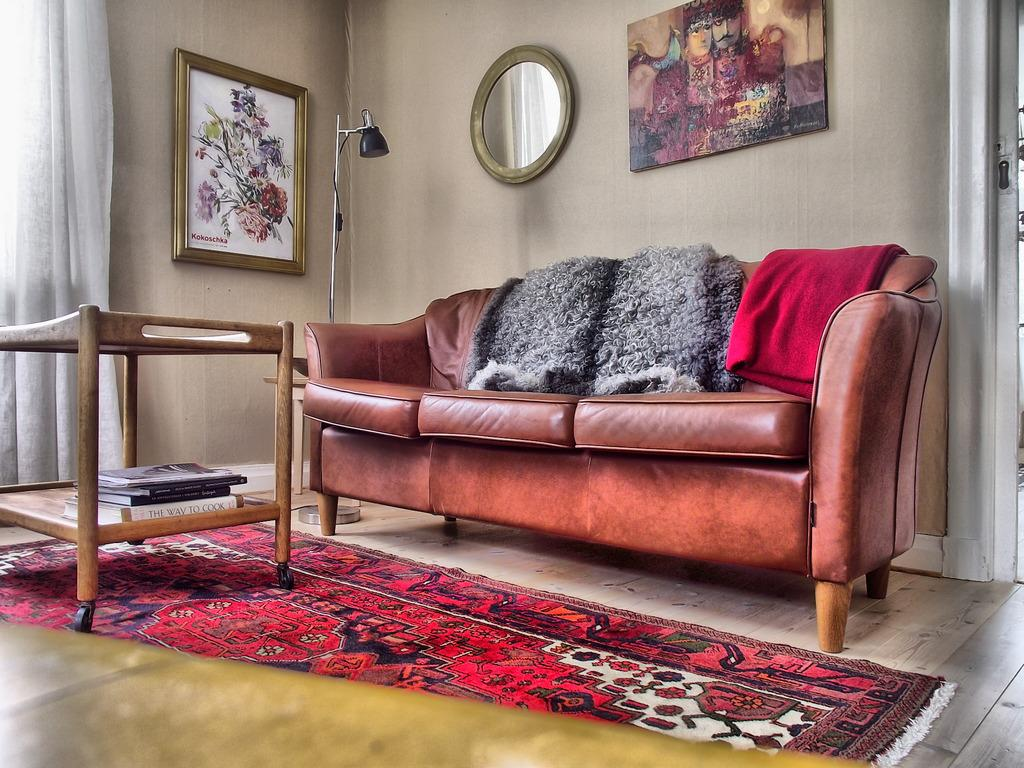What type of furniture is present in the image? There is a couch in the image. What type of decorative items can be seen in the image? There is a picture, a mirror, a poster, and a lantern lamp with a stand in the image. What type of surface is present in the image? There is a table in the image. What type of reading material is present in the image? There are books in the image. What type of flooring is present in the image? The floor has a carpet in the image. What type of knife is used to cut the lead in the image? There is no knife or lead present in the image. How does the person in the image cough while reading the book? There is no person present in the image, and therefore no one is reading a book or coughing. 